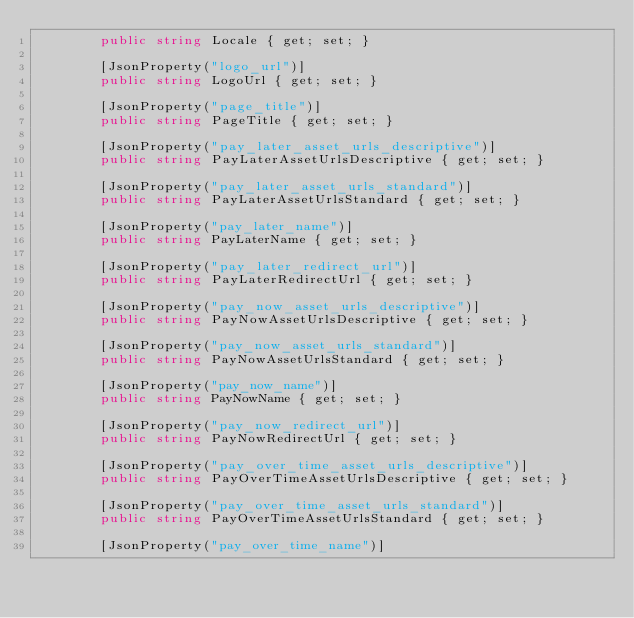Convert code to text. <code><loc_0><loc_0><loc_500><loc_500><_C#_>        public string Locale { get; set; }

        [JsonProperty("logo_url")]
        public string LogoUrl { get; set; }

        [JsonProperty("page_title")]
        public string PageTitle { get; set; }

        [JsonProperty("pay_later_asset_urls_descriptive")]
        public string PayLaterAssetUrlsDescriptive { get; set; }

        [JsonProperty("pay_later_asset_urls_standard")]
        public string PayLaterAssetUrlsStandard { get; set; }

        [JsonProperty("pay_later_name")]
        public string PayLaterName { get; set; }

        [JsonProperty("pay_later_redirect_url")]
        public string PayLaterRedirectUrl { get; set; }

        [JsonProperty("pay_now_asset_urls_descriptive")]
        public string PayNowAssetUrlsDescriptive { get; set; }

        [JsonProperty("pay_now_asset_urls_standard")]
        public string PayNowAssetUrlsStandard { get; set; }

        [JsonProperty("pay_now_name")]
        public string PayNowName { get; set; }

        [JsonProperty("pay_now_redirect_url")]
        public string PayNowRedirectUrl { get; set; }

        [JsonProperty("pay_over_time_asset_urls_descriptive")]
        public string PayOverTimeAssetUrlsDescriptive { get; set; }

        [JsonProperty("pay_over_time_asset_urls_standard")]
        public string PayOverTimeAssetUrlsStandard { get; set; }

        [JsonProperty("pay_over_time_name")]</code> 